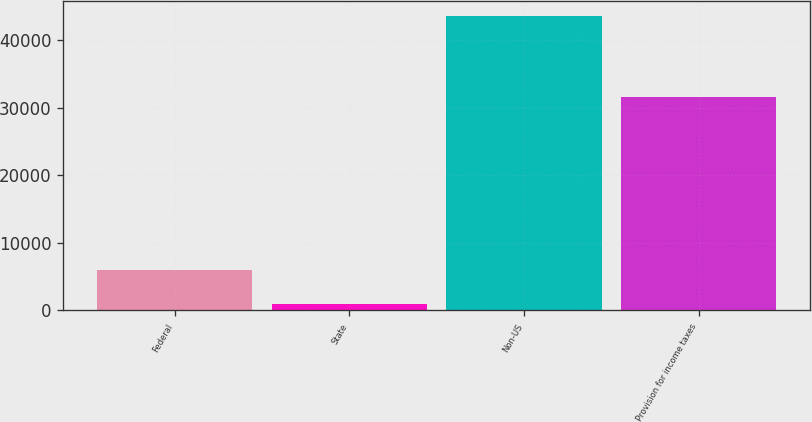<chart> <loc_0><loc_0><loc_500><loc_500><bar_chart><fcel>Federal<fcel>State<fcel>Non-US<fcel>Provision for income taxes<nl><fcel>5973<fcel>984<fcel>43614<fcel>31671<nl></chart> 